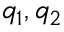<formula> <loc_0><loc_0><loc_500><loc_500>q _ { 1 } , q _ { 2 }</formula> 